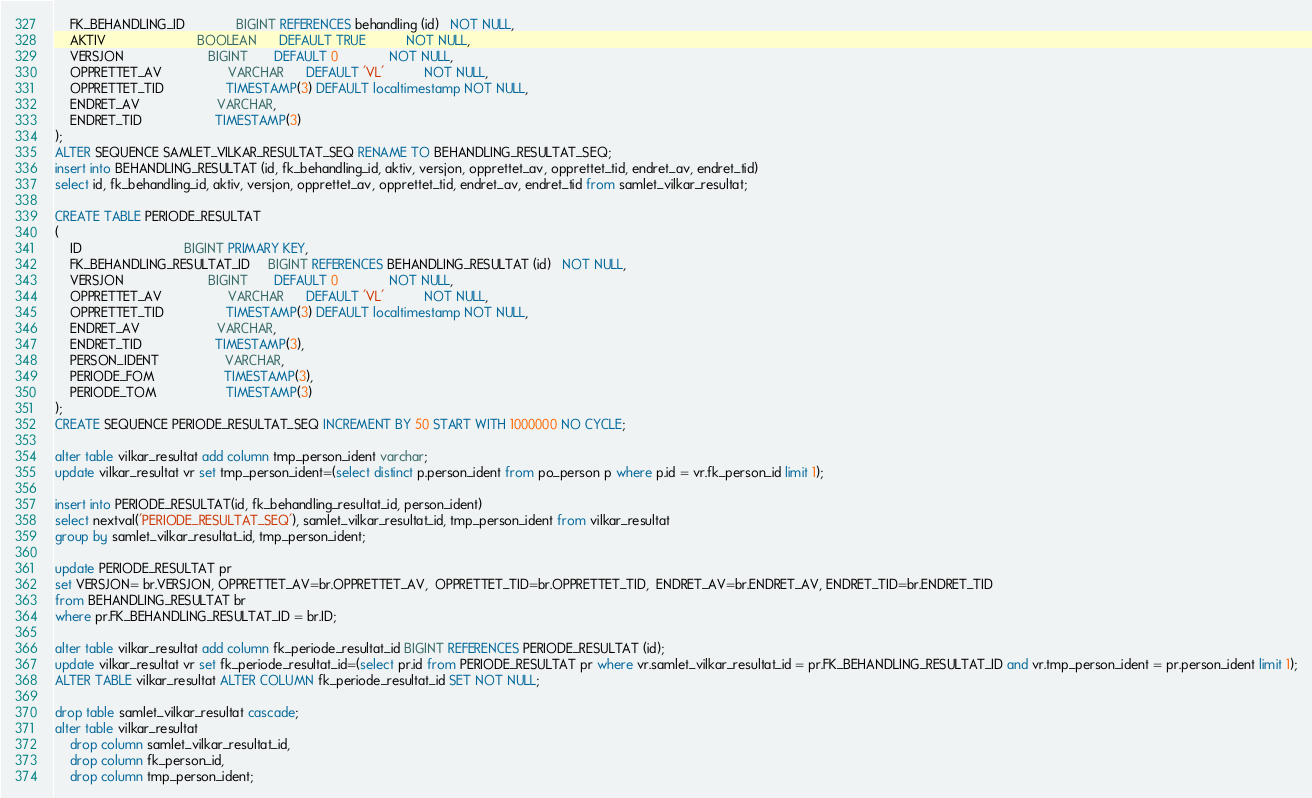<code> <loc_0><loc_0><loc_500><loc_500><_SQL_>    FK_BEHANDLING_ID              BIGINT REFERENCES behandling (id)   NOT NULL,
    AKTIV                         BOOLEAN      DEFAULT TRUE           NOT NULL,
    VERSJON                       BIGINT       DEFAULT 0              NOT NULL,
    OPPRETTET_AV                  VARCHAR      DEFAULT 'VL'           NOT NULL,
    OPPRETTET_TID                 TIMESTAMP(3) DEFAULT localtimestamp NOT NULL,
    ENDRET_AV                     VARCHAR,
    ENDRET_TID                    TIMESTAMP(3)
);
ALTER SEQUENCE SAMLET_VILKAR_RESULTAT_SEQ RENAME TO BEHANDLING_RESULTAT_SEQ;
insert into BEHANDLING_RESULTAT (id, fk_behandling_id, aktiv, versjon, opprettet_av, opprettet_tid, endret_av, endret_tid)
select id, fk_behandling_id, aktiv, versjon, opprettet_av, opprettet_tid, endret_av, endret_tid from samlet_vilkar_resultat;

CREATE TABLE PERIODE_RESULTAT
(
    ID                            BIGINT PRIMARY KEY,
    FK_BEHANDLING_RESULTAT_ID     BIGINT REFERENCES BEHANDLING_RESULTAT (id)   NOT NULL,
    VERSJON                       BIGINT       DEFAULT 0              NOT NULL,
    OPPRETTET_AV                  VARCHAR      DEFAULT 'VL'           NOT NULL,
    OPPRETTET_TID                 TIMESTAMP(3) DEFAULT localtimestamp NOT NULL,
    ENDRET_AV                     VARCHAR,
    ENDRET_TID                    TIMESTAMP(3),
    PERSON_IDENT                  VARCHAR,
    PERIODE_FOM                   TIMESTAMP(3),
    PERIODE_TOM                   TIMESTAMP(3)
);
CREATE SEQUENCE PERIODE_RESULTAT_SEQ INCREMENT BY 50 START WITH 1000000 NO CYCLE;

alter table vilkar_resultat add column tmp_person_ident varchar;
update vilkar_resultat vr set tmp_person_ident=(select distinct p.person_ident from po_person p where p.id = vr.fk_person_id limit 1);

insert into PERIODE_RESULTAT(id, fk_behandling_resultat_id, person_ident)
select nextval('PERIODE_RESULTAT_SEQ'), samlet_vilkar_resultat_id, tmp_person_ident from vilkar_resultat
group by samlet_vilkar_resultat_id, tmp_person_ident;

update PERIODE_RESULTAT pr
set VERSJON= br.VERSJON, OPPRETTET_AV=br.OPPRETTET_AV,  OPPRETTET_TID=br.OPPRETTET_TID,  ENDRET_AV=br.ENDRET_AV, ENDRET_TID=br.ENDRET_TID
from BEHANDLING_RESULTAT br
where pr.FK_BEHANDLING_RESULTAT_ID = br.ID;

alter table vilkar_resultat add column fk_periode_resultat_id BIGINT REFERENCES PERIODE_RESULTAT (id);
update vilkar_resultat vr set fk_periode_resultat_id=(select pr.id from PERIODE_RESULTAT pr where vr.samlet_vilkar_resultat_id = pr.FK_BEHANDLING_RESULTAT_ID and vr.tmp_person_ident = pr.person_ident limit 1);
ALTER TABLE vilkar_resultat ALTER COLUMN fk_periode_resultat_id SET NOT NULL;

drop table samlet_vilkar_resultat cascade;
alter table vilkar_resultat
    drop column samlet_vilkar_resultat_id,
    drop column fk_person_id,
    drop column tmp_person_ident;</code> 